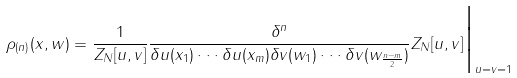<formula> <loc_0><loc_0><loc_500><loc_500>\rho _ { ( n ) } ( x , w ) = \frac { 1 } { Z _ { N } [ u , v ] } \frac { \delta ^ { n } } { \delta u ( x _ { 1 } ) \cdot \cdot \cdot \delta u ( x _ { m } ) \delta v ( w _ { 1 } ) \cdot \cdot \cdot \delta v ( w _ { \frac { n - m } { 2 } } ) } Z _ { N } [ u , v ] { \Big | } _ { u = v = 1 }</formula> 